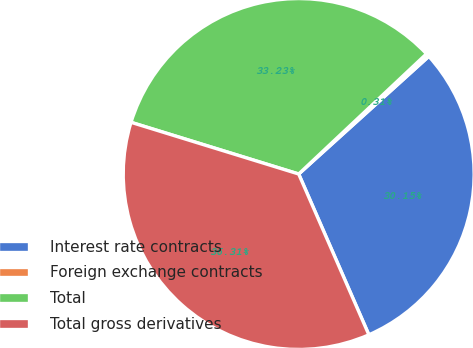Convert chart to OTSL. <chart><loc_0><loc_0><loc_500><loc_500><pie_chart><fcel>Interest rate contracts<fcel>Foreign exchange contracts<fcel>Total<fcel>Total gross derivatives<nl><fcel>30.15%<fcel>0.31%<fcel>33.23%<fcel>36.31%<nl></chart> 